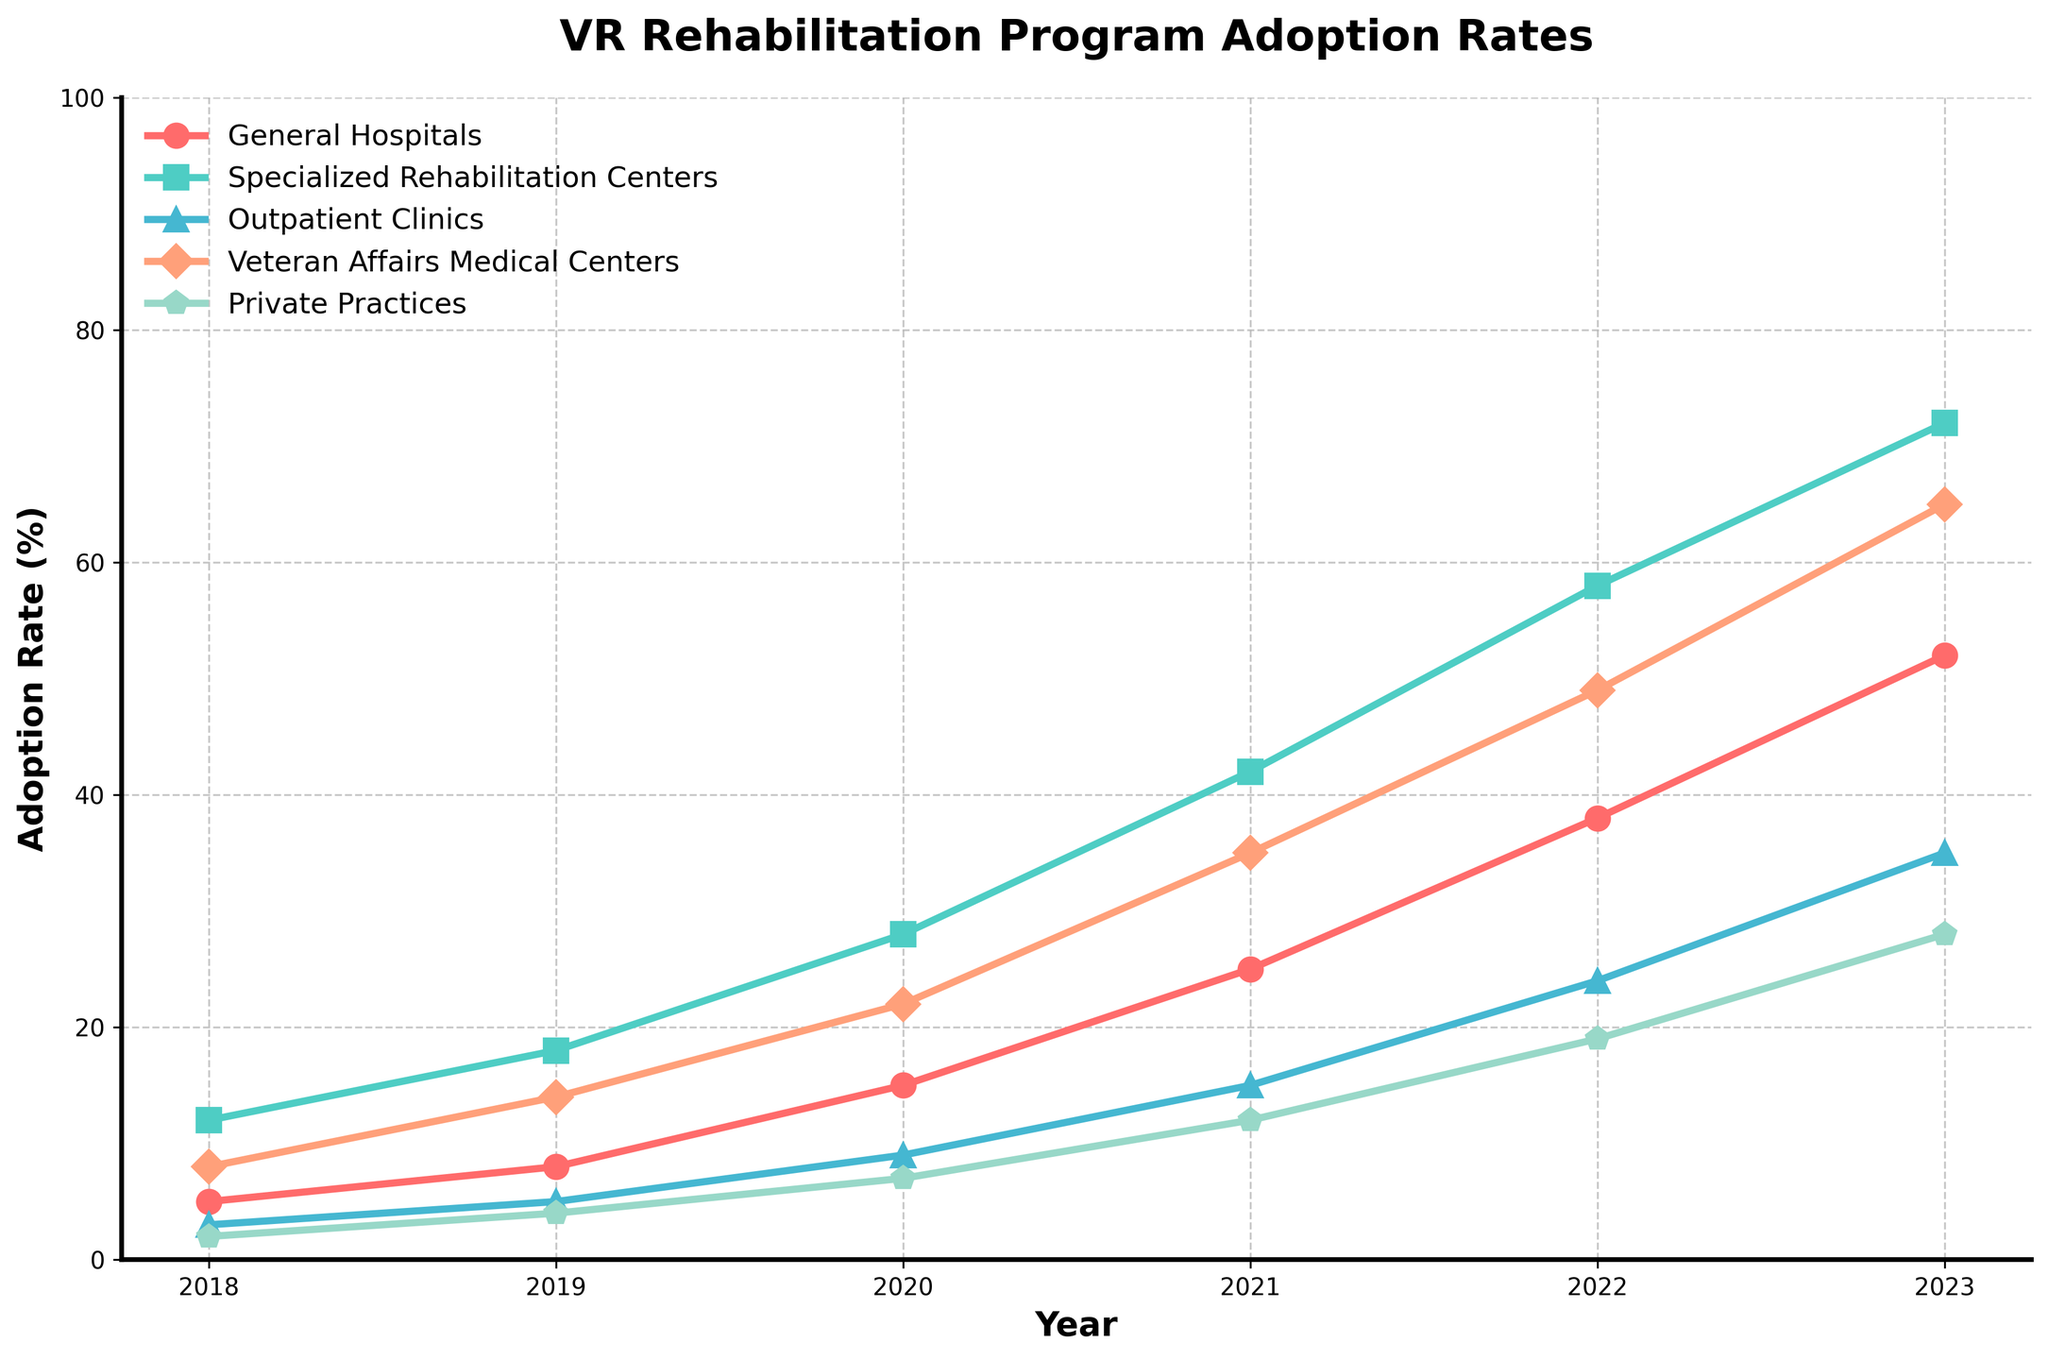What's the trend in the adoption rate of VR rehabilitation programs at General Hospitals from 2018 to 2023? From the line chart, trace the points for General Hospitals from 2018 to 2023. The adoption rate increases every year. Specifically, it rises from 5% in 2018 to 52% in 2023.
Answer: Increasing trend Compare the adoption rates of VR rehabilitation programs between Specialized Rehabilitation Centers and Private Practices in 2020. Which has a higher rate? In 2020, look at the data points for both Specialized Rehabilitation Centers and Private Practices. Specialized Rehabilitation Centers have an adoption rate of 28%, while Private Practices have 7%.
Answer: Specialized Rehabilitation Centers What is the average adoption rate of VR rehabilitation programs for Veteran Affairs Medical Centers from 2018 to 2023? First, find the adoption rates for Veteran Affairs Medical Centers over the years: 8%, 14%, 22%, 35%, 49%, 65%. Sum these percentages: 8 + 14 + 22 + 35 + 49 + 65 = 193. Now divide by the number of years, which is 6. 193 / 6 = 32.17%.
Answer: 32.17% Which medical facility shows the steepest increase in the adoption rate of VR rehabilitation programs from 2018 to 2023? To determine this, compare the slopes of the lines representing each facility. The steepest increase is shown by the Specialized Rehabilitation Centers, rising from 12% in 2018 to 72% in 2023, indicating a significant increase.
Answer: Specialized Rehabilitation Centers In 2022, what is the difference in the adoption rate of VR rehabilitation programs between General Hospitals and Outpatient Clinics? Look at the adoption rates in 2022 for both General Hospitals (38%) and Outpatient Clinics (24%). Subtract the smaller from the larger: 38% - 24% = 14%.
Answer: 14% Which facility had the least change in adoption rate from 2018 to 2023? To find the facility with the least change, calculate the difference between 2018 and 2023 for each facility. The smallest change is for Private Practices (28% - 2% = 26%).
Answer: Private Practices Compare the adoption rates of General Hospitals and Veteran Affairs Medical Centers in 2019. Which has a lower rate? In 2019, identify the adoption rates for General Hospitals (8%) and Veteran Affairs Medical Centers (14%). General Hospitals have a lower rate.
Answer: General Hospitals How does the adoption rate of Outpatient Clinics in 2023 compare to its rate in 2020? Look at the adoption rate for Outpatient Clinics in 2023 (35%) and in 2020 (9%). In 2023, the rate is significantly higher by 26%.
Answer: Higher By what percentage did the adoption rate for Specialized Rehabilitation Centers increase from 2018 to 2023? Find the adoption rates for 2018 (12%) and 2023 (72%). Calculate the difference: 72% - 12% = 60%.
Answer: 60% What is the combined total increase in adoption rates for all facilities from 2018 to 2023? Calculate the increase by subtracting 2018 rates from 2023 rates for all facilities and then add them up: General Hospitals (52% - 5% = 47%), Specialized Rehabilitation Centers (72% - 12% = 60%), Outpatient Clinics (35% - 3% = 32%), Veteran Affairs Medical Centers (65% - 8% = 57%), Private Practices (28% - 2% = 26%). Sum the increases: 47 + 60 + 32 + 57 + 26 = 222%.
Answer: 222% 